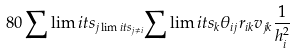Convert formula to latex. <formula><loc_0><loc_0><loc_500><loc_500>8 0 \sum \lim i t s _ { j \lim i t s _ { j \ne i } } { \sum \lim i t s _ { k } { { \theta _ { i j } } { r _ { i k } } { v _ { j k } } \frac { 1 } { h _ { i } ^ { 2 } } } }</formula> 